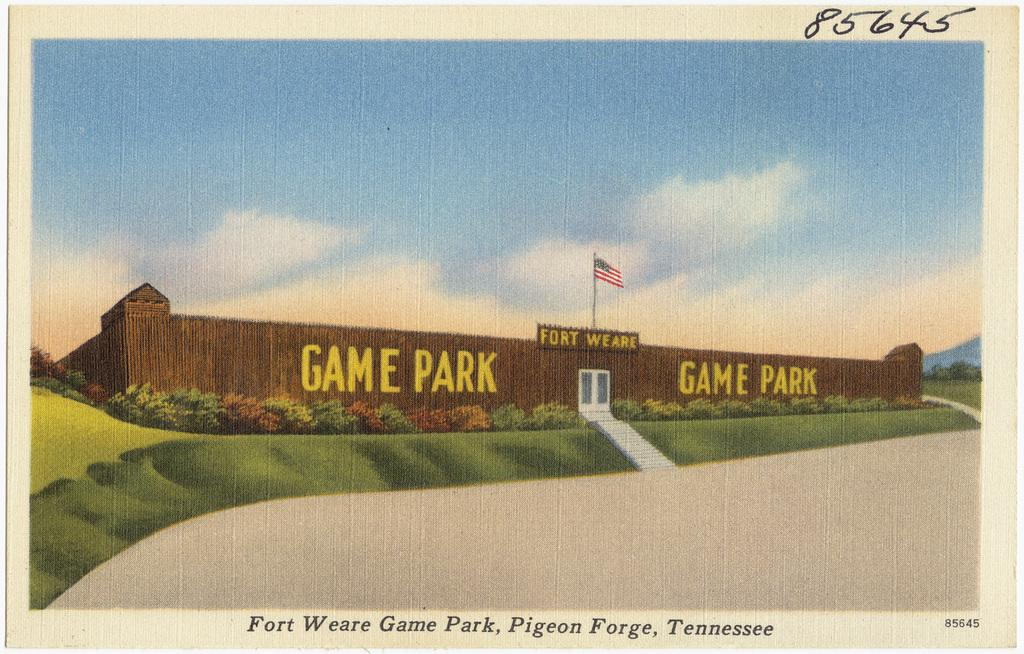<image>
Relay a brief, clear account of the picture shown. a building that says game park on it 